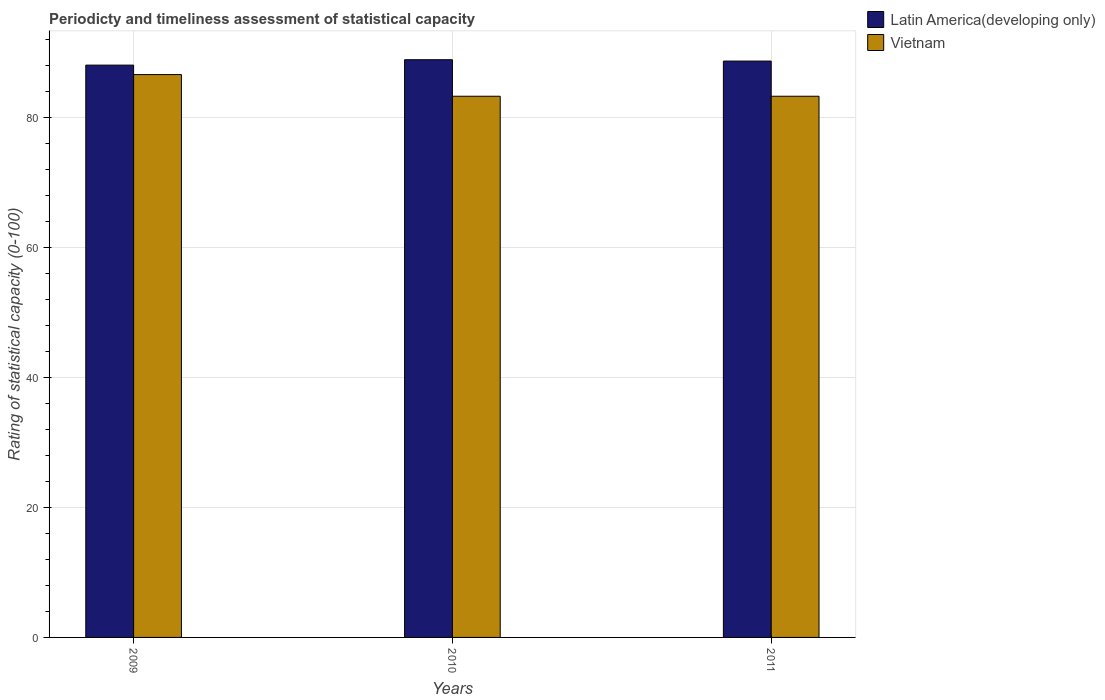How many different coloured bars are there?
Provide a succinct answer. 2. How many groups of bars are there?
Offer a terse response. 3. How many bars are there on the 1st tick from the left?
Give a very brief answer. 2. How many bars are there on the 2nd tick from the right?
Your response must be concise. 2. What is the label of the 2nd group of bars from the left?
Your answer should be compact. 2010. In how many cases, is the number of bars for a given year not equal to the number of legend labels?
Ensure brevity in your answer.  0. What is the rating of statistical capacity in Latin America(developing only) in 2009?
Give a very brief answer. 88.12. Across all years, what is the maximum rating of statistical capacity in Vietnam?
Offer a terse response. 86.67. Across all years, what is the minimum rating of statistical capacity in Latin America(developing only)?
Your answer should be compact. 88.12. In which year was the rating of statistical capacity in Latin America(developing only) maximum?
Provide a succinct answer. 2010. In which year was the rating of statistical capacity in Latin America(developing only) minimum?
Your answer should be very brief. 2009. What is the total rating of statistical capacity in Latin America(developing only) in the graph?
Ensure brevity in your answer.  265.83. What is the difference between the rating of statistical capacity in Vietnam in 2009 and that in 2010?
Provide a succinct answer. 3.33. What is the difference between the rating of statistical capacity in Latin America(developing only) in 2010 and the rating of statistical capacity in Vietnam in 2009?
Your response must be concise. 2.29. What is the average rating of statistical capacity in Latin America(developing only) per year?
Provide a succinct answer. 88.61. In the year 2011, what is the difference between the rating of statistical capacity in Vietnam and rating of statistical capacity in Latin America(developing only)?
Offer a very short reply. -5.42. In how many years, is the rating of statistical capacity in Vietnam greater than 80?
Ensure brevity in your answer.  3. What is the ratio of the rating of statistical capacity in Latin America(developing only) in 2010 to that in 2011?
Make the answer very short. 1. Is the difference between the rating of statistical capacity in Vietnam in 2010 and 2011 greater than the difference between the rating of statistical capacity in Latin America(developing only) in 2010 and 2011?
Give a very brief answer. No. What is the difference between the highest and the second highest rating of statistical capacity in Vietnam?
Offer a terse response. 3.33. What is the difference between the highest and the lowest rating of statistical capacity in Vietnam?
Your answer should be very brief. 3.33. What does the 1st bar from the left in 2010 represents?
Ensure brevity in your answer.  Latin America(developing only). What does the 2nd bar from the right in 2011 represents?
Your answer should be compact. Latin America(developing only). How many years are there in the graph?
Your response must be concise. 3. Are the values on the major ticks of Y-axis written in scientific E-notation?
Offer a terse response. No. Does the graph contain any zero values?
Keep it short and to the point. No. What is the title of the graph?
Your response must be concise. Periodicty and timeliness assessment of statistical capacity. What is the label or title of the X-axis?
Offer a very short reply. Years. What is the label or title of the Y-axis?
Your answer should be very brief. Rating of statistical capacity (0-100). What is the Rating of statistical capacity (0-100) in Latin America(developing only) in 2009?
Your answer should be very brief. 88.12. What is the Rating of statistical capacity (0-100) in Vietnam in 2009?
Give a very brief answer. 86.67. What is the Rating of statistical capacity (0-100) of Latin America(developing only) in 2010?
Offer a terse response. 88.96. What is the Rating of statistical capacity (0-100) in Vietnam in 2010?
Provide a succinct answer. 83.33. What is the Rating of statistical capacity (0-100) of Latin America(developing only) in 2011?
Provide a short and direct response. 88.75. What is the Rating of statistical capacity (0-100) in Vietnam in 2011?
Your answer should be very brief. 83.33. Across all years, what is the maximum Rating of statistical capacity (0-100) in Latin America(developing only)?
Make the answer very short. 88.96. Across all years, what is the maximum Rating of statistical capacity (0-100) of Vietnam?
Ensure brevity in your answer.  86.67. Across all years, what is the minimum Rating of statistical capacity (0-100) in Latin America(developing only)?
Your response must be concise. 88.12. Across all years, what is the minimum Rating of statistical capacity (0-100) in Vietnam?
Offer a very short reply. 83.33. What is the total Rating of statistical capacity (0-100) of Latin America(developing only) in the graph?
Your response must be concise. 265.83. What is the total Rating of statistical capacity (0-100) in Vietnam in the graph?
Ensure brevity in your answer.  253.33. What is the difference between the Rating of statistical capacity (0-100) of Latin America(developing only) in 2009 and that in 2010?
Provide a succinct answer. -0.83. What is the difference between the Rating of statistical capacity (0-100) of Latin America(developing only) in 2009 and that in 2011?
Offer a terse response. -0.62. What is the difference between the Rating of statistical capacity (0-100) in Vietnam in 2009 and that in 2011?
Offer a very short reply. 3.33. What is the difference between the Rating of statistical capacity (0-100) in Latin America(developing only) in 2010 and that in 2011?
Give a very brief answer. 0.21. What is the difference between the Rating of statistical capacity (0-100) in Vietnam in 2010 and that in 2011?
Offer a very short reply. 0. What is the difference between the Rating of statistical capacity (0-100) in Latin America(developing only) in 2009 and the Rating of statistical capacity (0-100) in Vietnam in 2010?
Your response must be concise. 4.79. What is the difference between the Rating of statistical capacity (0-100) in Latin America(developing only) in 2009 and the Rating of statistical capacity (0-100) in Vietnam in 2011?
Make the answer very short. 4.79. What is the difference between the Rating of statistical capacity (0-100) of Latin America(developing only) in 2010 and the Rating of statistical capacity (0-100) of Vietnam in 2011?
Your answer should be very brief. 5.62. What is the average Rating of statistical capacity (0-100) in Latin America(developing only) per year?
Your answer should be compact. 88.61. What is the average Rating of statistical capacity (0-100) in Vietnam per year?
Keep it short and to the point. 84.44. In the year 2009, what is the difference between the Rating of statistical capacity (0-100) of Latin America(developing only) and Rating of statistical capacity (0-100) of Vietnam?
Your response must be concise. 1.46. In the year 2010, what is the difference between the Rating of statistical capacity (0-100) of Latin America(developing only) and Rating of statistical capacity (0-100) of Vietnam?
Give a very brief answer. 5.62. In the year 2011, what is the difference between the Rating of statistical capacity (0-100) in Latin America(developing only) and Rating of statistical capacity (0-100) in Vietnam?
Provide a short and direct response. 5.42. What is the ratio of the Rating of statistical capacity (0-100) of Latin America(developing only) in 2009 to that in 2010?
Your answer should be compact. 0.99. What is the ratio of the Rating of statistical capacity (0-100) of Vietnam in 2009 to that in 2011?
Offer a terse response. 1.04. What is the ratio of the Rating of statistical capacity (0-100) in Latin America(developing only) in 2010 to that in 2011?
Provide a short and direct response. 1. What is the ratio of the Rating of statistical capacity (0-100) in Vietnam in 2010 to that in 2011?
Offer a terse response. 1. What is the difference between the highest and the second highest Rating of statistical capacity (0-100) of Latin America(developing only)?
Offer a terse response. 0.21. What is the difference between the highest and the second highest Rating of statistical capacity (0-100) of Vietnam?
Your answer should be very brief. 3.33. What is the difference between the highest and the lowest Rating of statistical capacity (0-100) in Latin America(developing only)?
Make the answer very short. 0.83. What is the difference between the highest and the lowest Rating of statistical capacity (0-100) in Vietnam?
Your response must be concise. 3.33. 